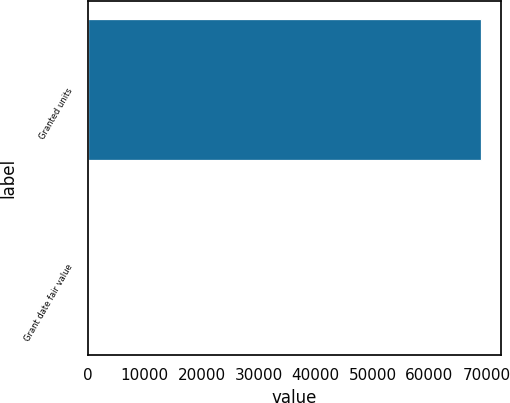Convert chart. <chart><loc_0><loc_0><loc_500><loc_500><bar_chart><fcel>Granted units<fcel>Grant date fair value<nl><fcel>69044<fcel>22.6<nl></chart> 